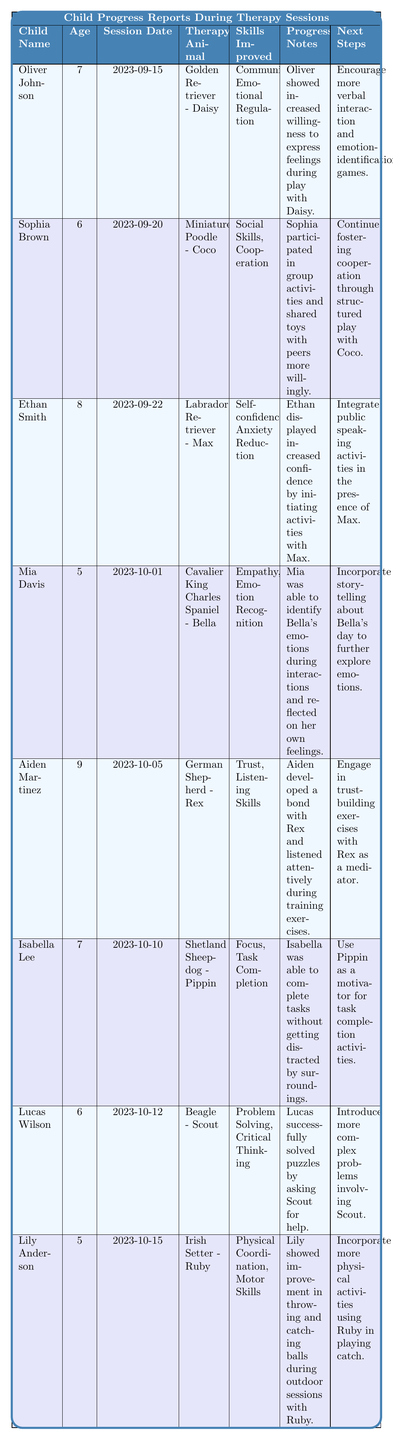What therapy animal was used in Ethan Smith's session? The table lists Ethan Smith's therapy animal as "Labrador Retriever - Max" in the corresponding row.
Answer: Labrador Retriever - Max How many skills improved for Mia Davis during her therapy session? In the row for Mia Davis, it states two skills improved: "Empathy" and "Emotion Recognition".
Answer: 2 Which child showed progress in "Social Skills"? The table indicates that Sophia Brown improved her "Social Skills" during her session, as noted in her row.
Answer: Sophia Brown What was the age of the youngest child in the table? The ages of the children listed are 5 (Mia Davis and Lily Anderson), 6 (Sophia Brown and Lucas Wilson), 7 (Oliver Johnson and Isabella Lee), and 8 (Ethan Smith), with the minimum being 5 years.
Answer: 5 Did any child achieve improvement in physical skills? Both Mia Davis and Lily Anderson show improved skills, but only Lily Anderson lists "Physical Coordination" and "Motor Skills", confirming she achieved improvement in physical skills.
Answer: Yes What is the next step for Aiden Martinez's therapy session? The row for Aiden Martinez specifies the next step as "Engage in trust-building exercises with Rex as a mediator."
Answer: Engage in trust-building exercises with Rex Which therapy animal is associated with Isabella Lee? The table specifies that Isabella Lee's therapy animal is "Shetland Sheepdog - Pippin".
Answer: Shetland Sheepdog - Pippin What skills did Lucas Wilson improve in his therapy session? The row for Lucas Wilson notes that he improved in "Problem Solving" and "Critical Thinking".
Answer: Problem Solving, Critical Thinking Which child's progress notes mention outdoor sessions? The notes for Lily Anderson state “Lily showed improvement in throwing and catching balls during outdoor sessions with Ruby."
Answer: Lily Anderson Which child has the next steps related to public speaking? The next steps for Ethan Smith include involving public speaking activities, as mentioned in his row.
Answer: Ethan Smith How many children improved their emotional skills? The children who improved their emotional skills are Oliver Johnson, Mia Davis, and Ethan Smith. Counting them gives a total of three.
Answer: 3 